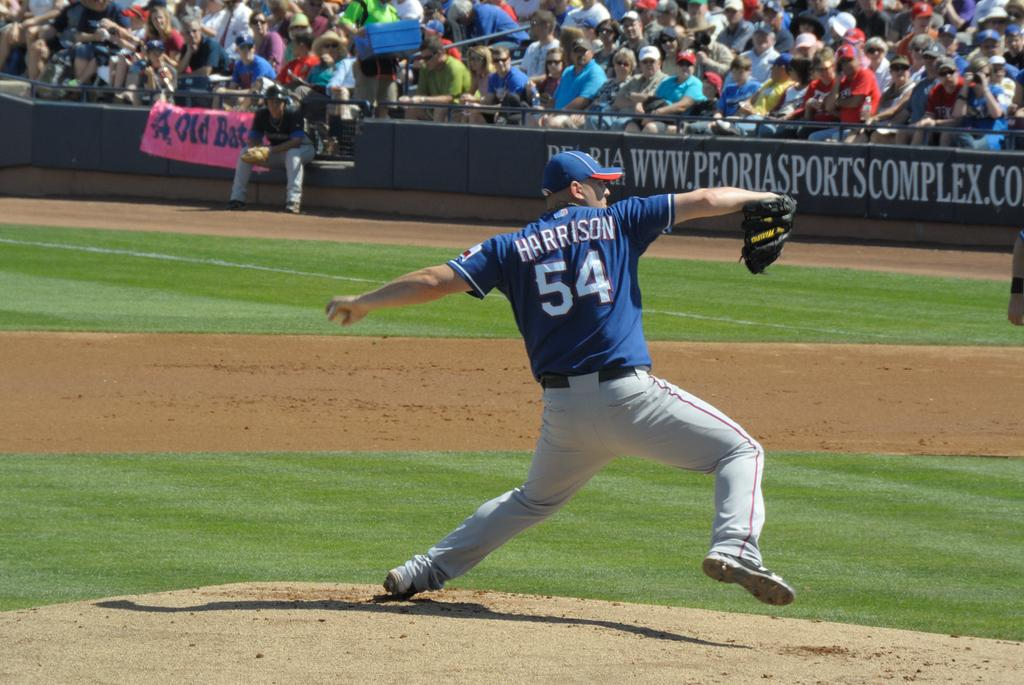What type of vegetation is present in the image? There is grass in the image. What can be seen hanging or displayed in the image? There is a banner in the image. What are the people in the image doing? There are people sitting on chairs in the image. Can you describe the clothing of one of the individuals in the image? There is a man wearing a blue t-shirt and a blue hat in the image. What songs are being sung by the maid in the image? There is no maid present in the image, and no one is singing songs. What type of pets can be seen playing with the people in the image? There are no pets visible in the image; it only features people sitting on chairs and a man wearing a blue t-shirt and hat. 